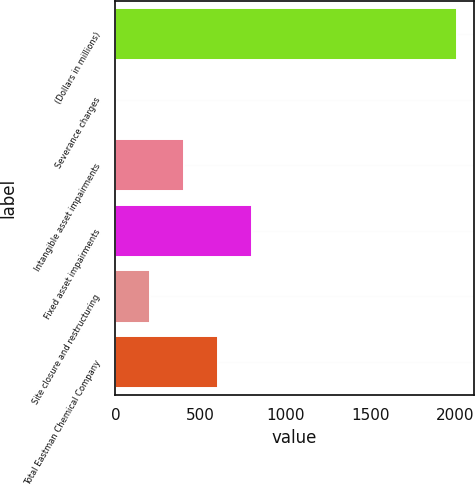Convert chart to OTSL. <chart><loc_0><loc_0><loc_500><loc_500><bar_chart><fcel>(Dollars in millions)<fcel>Severance charges<fcel>Intangible asset impairments<fcel>Fixed asset impairments<fcel>Site closure and restructuring<fcel>Total Eastman Chemical Company<nl><fcel>2007<fcel>1<fcel>402.2<fcel>803.4<fcel>201.6<fcel>602.8<nl></chart> 